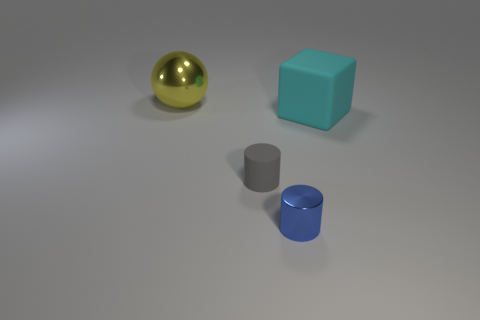There is a object that is right of the shiny thing that is in front of the yellow shiny ball; what shape is it?
Your answer should be compact. Cube. Is there any other thing that has the same shape as the big matte object?
Your answer should be very brief. No. What color is the small shiny object that is the same shape as the small gray rubber object?
Your response must be concise. Blue. There is a object that is behind the small rubber object and on the right side of the tiny rubber object; what is its shape?
Your response must be concise. Cube. Is the number of gray matte things less than the number of matte things?
Your response must be concise. Yes. Is there a large red metallic object?
Offer a very short reply. No. How many other things are the same size as the gray object?
Give a very brief answer. 1. Do the yellow ball and the cylinder that is right of the tiny rubber cylinder have the same material?
Your response must be concise. Yes. Is the number of matte blocks left of the gray rubber object the same as the number of yellow objects left of the metallic cylinder?
Offer a very short reply. No. What material is the tiny gray cylinder?
Keep it short and to the point. Rubber. 